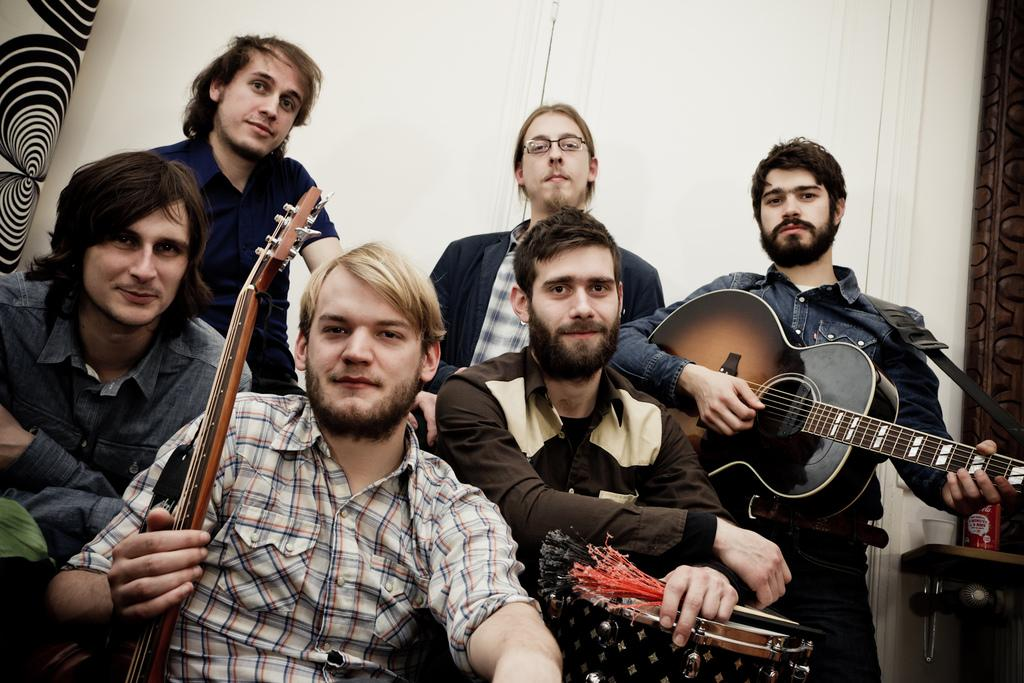What is the main subject of the image? The main subject of the image is a group of men. What are the men holding in the image? One man is holding a guitar, and another man is holding drums. What can be seen in the background of the image? There is a wall and a door in the background of the image. What type of jewel is the man wearing on his head in the image? There is no man wearing a jewel on his head in the image; the men are holding musical instruments. 